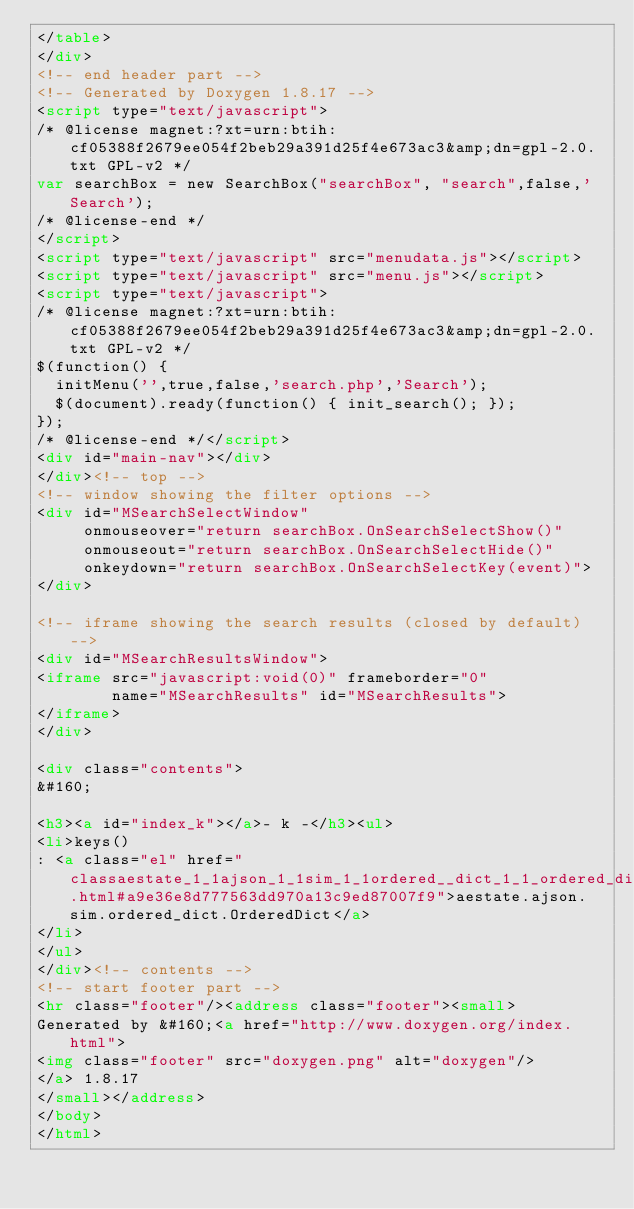Convert code to text. <code><loc_0><loc_0><loc_500><loc_500><_HTML_></table>
</div>
<!-- end header part -->
<!-- Generated by Doxygen 1.8.17 -->
<script type="text/javascript">
/* @license magnet:?xt=urn:btih:cf05388f2679ee054f2beb29a391d25f4e673ac3&amp;dn=gpl-2.0.txt GPL-v2 */
var searchBox = new SearchBox("searchBox", "search",false,'Search');
/* @license-end */
</script>
<script type="text/javascript" src="menudata.js"></script>
<script type="text/javascript" src="menu.js"></script>
<script type="text/javascript">
/* @license magnet:?xt=urn:btih:cf05388f2679ee054f2beb29a391d25f4e673ac3&amp;dn=gpl-2.0.txt GPL-v2 */
$(function() {
  initMenu('',true,false,'search.php','Search');
  $(document).ready(function() { init_search(); });
});
/* @license-end */</script>
<div id="main-nav"></div>
</div><!-- top -->
<!-- window showing the filter options -->
<div id="MSearchSelectWindow"
     onmouseover="return searchBox.OnSearchSelectShow()"
     onmouseout="return searchBox.OnSearchSelectHide()"
     onkeydown="return searchBox.OnSearchSelectKey(event)">
</div>

<!-- iframe showing the search results (closed by default) -->
<div id="MSearchResultsWindow">
<iframe src="javascript:void(0)" frameborder="0" 
        name="MSearchResults" id="MSearchResults">
</iframe>
</div>

<div class="contents">
&#160;

<h3><a id="index_k"></a>- k -</h3><ul>
<li>keys()
: <a class="el" href="classaestate_1_1ajson_1_1sim_1_1ordered__dict_1_1_ordered_dict.html#a9e36e8d777563dd970a13c9ed87007f9">aestate.ajson.sim.ordered_dict.OrderedDict</a>
</li>
</ul>
</div><!-- contents -->
<!-- start footer part -->
<hr class="footer"/><address class="footer"><small>
Generated by &#160;<a href="http://www.doxygen.org/index.html">
<img class="footer" src="doxygen.png" alt="doxygen"/>
</a> 1.8.17
</small></address>
</body>
</html>
</code> 